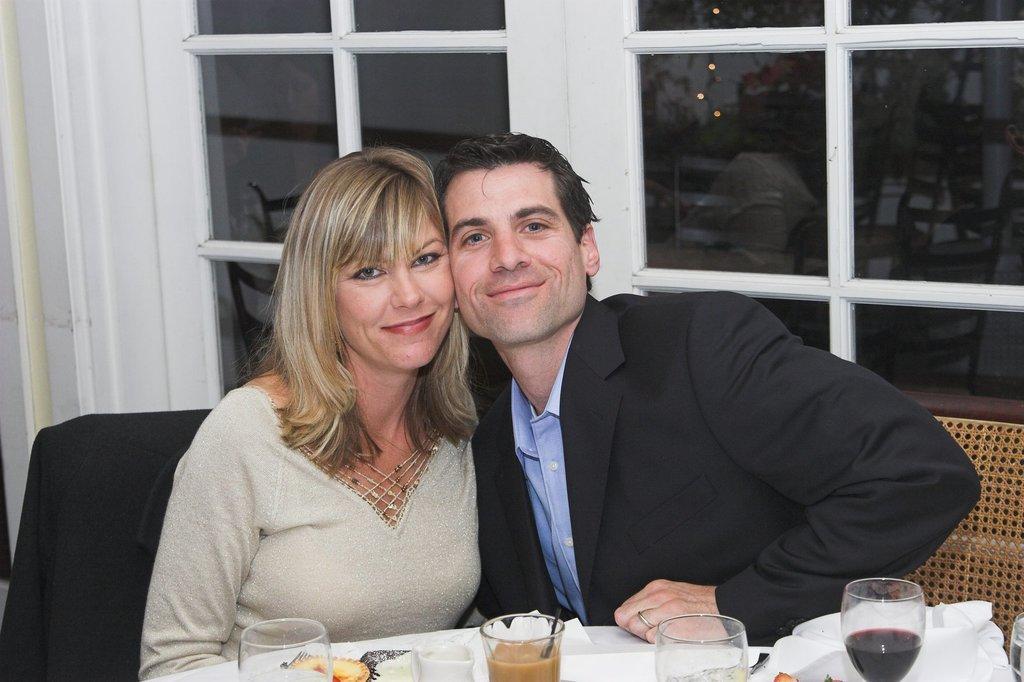In one or two sentences, can you explain what this image depicts? These two person sitting on the chair. On the background we can see glass window. We can able to see table. On the table we can see glass,food,papers. 